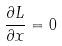<formula> <loc_0><loc_0><loc_500><loc_500>\frac { \partial L } { \partial x } = 0</formula> 